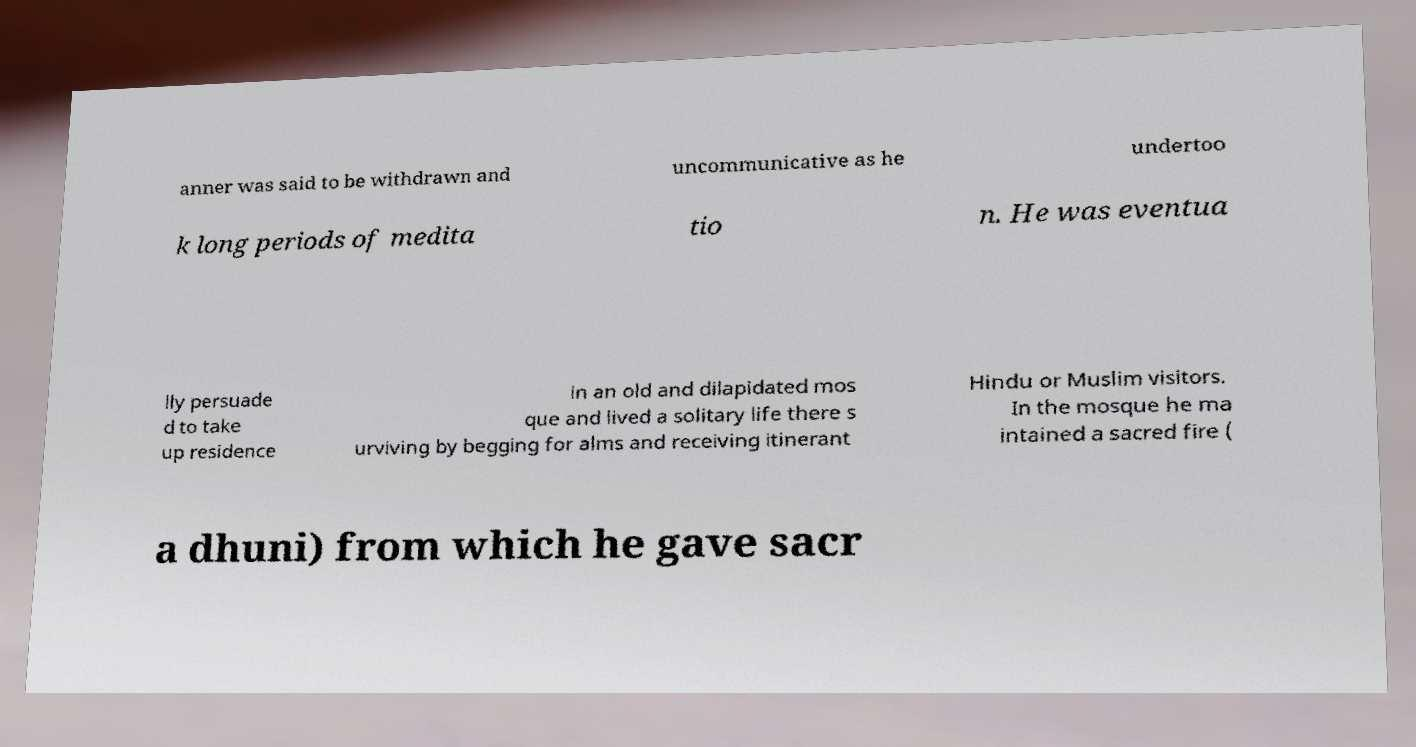I need the written content from this picture converted into text. Can you do that? anner was said to be withdrawn and uncommunicative as he undertoo k long periods of medita tio n. He was eventua lly persuade d to take up residence in an old and dilapidated mos que and lived a solitary life there s urviving by begging for alms and receiving itinerant Hindu or Muslim visitors. In the mosque he ma intained a sacred fire ( a dhuni) from which he gave sacr 